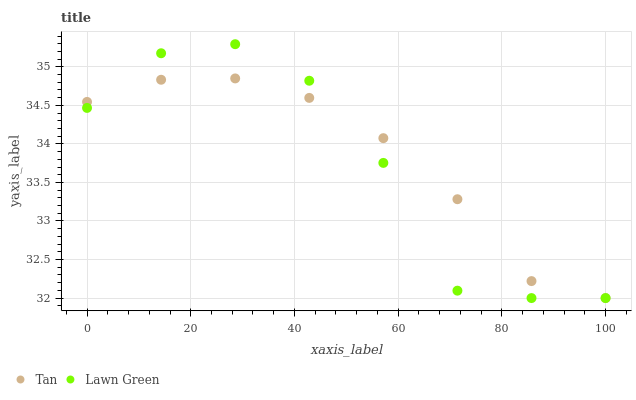Does Lawn Green have the minimum area under the curve?
Answer yes or no. Yes. Does Tan have the maximum area under the curve?
Answer yes or no. Yes. Does Tan have the minimum area under the curve?
Answer yes or no. No. Is Tan the smoothest?
Answer yes or no. Yes. Is Lawn Green the roughest?
Answer yes or no. Yes. Is Tan the roughest?
Answer yes or no. No. Does Lawn Green have the lowest value?
Answer yes or no. Yes. Does Lawn Green have the highest value?
Answer yes or no. Yes. Does Tan have the highest value?
Answer yes or no. No. Does Lawn Green intersect Tan?
Answer yes or no. Yes. Is Lawn Green less than Tan?
Answer yes or no. No. Is Lawn Green greater than Tan?
Answer yes or no. No. 